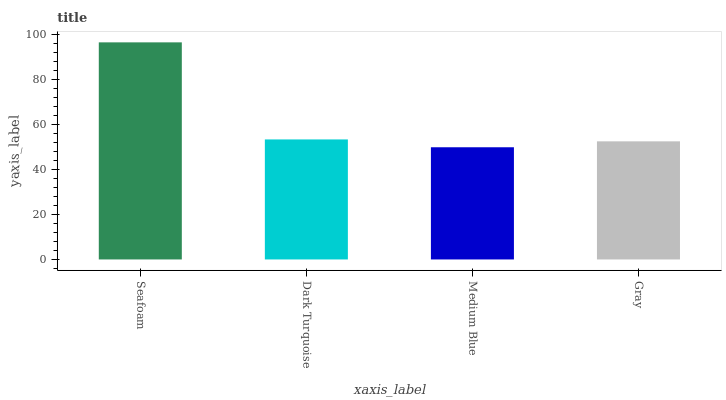Is Dark Turquoise the minimum?
Answer yes or no. No. Is Dark Turquoise the maximum?
Answer yes or no. No. Is Seafoam greater than Dark Turquoise?
Answer yes or no. Yes. Is Dark Turquoise less than Seafoam?
Answer yes or no. Yes. Is Dark Turquoise greater than Seafoam?
Answer yes or no. No. Is Seafoam less than Dark Turquoise?
Answer yes or no. No. Is Dark Turquoise the high median?
Answer yes or no. Yes. Is Gray the low median?
Answer yes or no. Yes. Is Gray the high median?
Answer yes or no. No. Is Seafoam the low median?
Answer yes or no. No. 